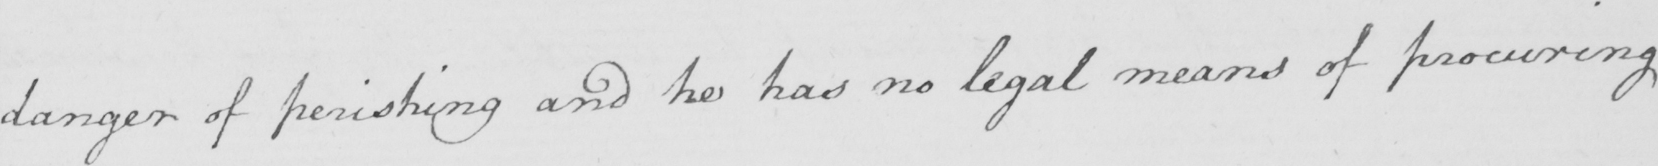Transcribe the text shown in this historical manuscript line. danger of perishing and he has no legal means of procuring 